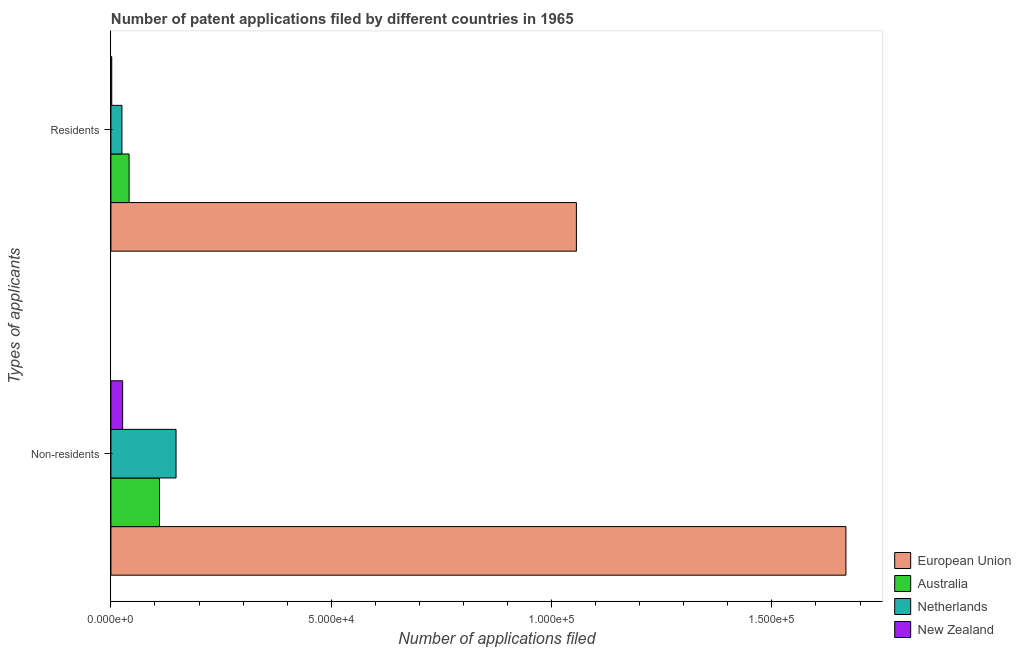How many different coloured bars are there?
Make the answer very short. 4. How many groups of bars are there?
Your answer should be compact. 2. Are the number of bars per tick equal to the number of legend labels?
Your answer should be compact. Yes. Are the number of bars on each tick of the Y-axis equal?
Give a very brief answer. Yes. What is the label of the 2nd group of bars from the top?
Your response must be concise. Non-residents. What is the number of patent applications by residents in European Union?
Keep it short and to the point. 1.06e+05. Across all countries, what is the maximum number of patent applications by non residents?
Your answer should be very brief. 1.67e+05. Across all countries, what is the minimum number of patent applications by non residents?
Offer a very short reply. 2662. In which country was the number of patent applications by non residents maximum?
Keep it short and to the point. European Union. In which country was the number of patent applications by non residents minimum?
Provide a succinct answer. New Zealand. What is the total number of patent applications by residents in the graph?
Offer a terse response. 1.12e+05. What is the difference between the number of patent applications by residents in New Zealand and that in Australia?
Offer a very short reply. -3935. What is the difference between the number of patent applications by residents in European Union and the number of patent applications by non residents in New Zealand?
Your answer should be very brief. 1.03e+05. What is the average number of patent applications by non residents per country?
Make the answer very short. 4.88e+04. What is the difference between the number of patent applications by residents and number of patent applications by non residents in European Union?
Your answer should be very brief. -6.12e+04. What is the ratio of the number of patent applications by non residents in Australia to that in European Union?
Your answer should be compact. 0.07. Is the number of patent applications by residents in European Union less than that in Australia?
Your answer should be compact. No. What does the 1st bar from the top in Residents represents?
Keep it short and to the point. New Zealand. What does the 4th bar from the bottom in Residents represents?
Your response must be concise. New Zealand. How many bars are there?
Provide a succinct answer. 8. How many countries are there in the graph?
Offer a terse response. 4. What is the difference between two consecutive major ticks on the X-axis?
Your answer should be very brief. 5.00e+04. Are the values on the major ticks of X-axis written in scientific E-notation?
Give a very brief answer. Yes. Does the graph contain any zero values?
Offer a very short reply. No. Where does the legend appear in the graph?
Provide a short and direct response. Bottom right. What is the title of the graph?
Keep it short and to the point. Number of patent applications filed by different countries in 1965. Does "Costa Rica" appear as one of the legend labels in the graph?
Your answer should be very brief. No. What is the label or title of the X-axis?
Make the answer very short. Number of applications filed. What is the label or title of the Y-axis?
Offer a very short reply. Types of applicants. What is the Number of applications filed of European Union in Non-residents?
Your answer should be very brief. 1.67e+05. What is the Number of applications filed of Australia in Non-residents?
Offer a very short reply. 1.10e+04. What is the Number of applications filed in Netherlands in Non-residents?
Provide a succinct answer. 1.48e+04. What is the Number of applications filed in New Zealand in Non-residents?
Provide a short and direct response. 2662. What is the Number of applications filed in European Union in Residents?
Provide a short and direct response. 1.06e+05. What is the Number of applications filed of Australia in Residents?
Your response must be concise. 4123. What is the Number of applications filed in Netherlands in Residents?
Offer a terse response. 2505. What is the Number of applications filed of New Zealand in Residents?
Make the answer very short. 188. Across all Types of applicants, what is the maximum Number of applications filed of European Union?
Provide a short and direct response. 1.67e+05. Across all Types of applicants, what is the maximum Number of applications filed in Australia?
Your response must be concise. 1.10e+04. Across all Types of applicants, what is the maximum Number of applications filed in Netherlands?
Your answer should be very brief. 1.48e+04. Across all Types of applicants, what is the maximum Number of applications filed of New Zealand?
Provide a succinct answer. 2662. Across all Types of applicants, what is the minimum Number of applications filed of European Union?
Provide a short and direct response. 1.06e+05. Across all Types of applicants, what is the minimum Number of applications filed of Australia?
Keep it short and to the point. 4123. Across all Types of applicants, what is the minimum Number of applications filed of Netherlands?
Your answer should be compact. 2505. Across all Types of applicants, what is the minimum Number of applications filed in New Zealand?
Your answer should be very brief. 188. What is the total Number of applications filed in European Union in the graph?
Your response must be concise. 2.72e+05. What is the total Number of applications filed in Australia in the graph?
Ensure brevity in your answer.  1.52e+04. What is the total Number of applications filed of Netherlands in the graph?
Give a very brief answer. 1.73e+04. What is the total Number of applications filed of New Zealand in the graph?
Keep it short and to the point. 2850. What is the difference between the Number of applications filed in European Union in Non-residents and that in Residents?
Offer a very short reply. 6.12e+04. What is the difference between the Number of applications filed of Australia in Non-residents and that in Residents?
Offer a terse response. 6904. What is the difference between the Number of applications filed of Netherlands in Non-residents and that in Residents?
Provide a short and direct response. 1.23e+04. What is the difference between the Number of applications filed in New Zealand in Non-residents and that in Residents?
Keep it short and to the point. 2474. What is the difference between the Number of applications filed of European Union in Non-residents and the Number of applications filed of Australia in Residents?
Provide a short and direct response. 1.63e+05. What is the difference between the Number of applications filed of European Union in Non-residents and the Number of applications filed of Netherlands in Residents?
Offer a terse response. 1.64e+05. What is the difference between the Number of applications filed in European Union in Non-residents and the Number of applications filed in New Zealand in Residents?
Your response must be concise. 1.67e+05. What is the difference between the Number of applications filed of Australia in Non-residents and the Number of applications filed of Netherlands in Residents?
Offer a terse response. 8522. What is the difference between the Number of applications filed in Australia in Non-residents and the Number of applications filed in New Zealand in Residents?
Your response must be concise. 1.08e+04. What is the difference between the Number of applications filed of Netherlands in Non-residents and the Number of applications filed of New Zealand in Residents?
Give a very brief answer. 1.46e+04. What is the average Number of applications filed in European Union per Types of applicants?
Your answer should be compact. 1.36e+05. What is the average Number of applications filed of Australia per Types of applicants?
Your response must be concise. 7575. What is the average Number of applications filed of Netherlands per Types of applicants?
Offer a very short reply. 8642. What is the average Number of applications filed in New Zealand per Types of applicants?
Provide a short and direct response. 1425. What is the difference between the Number of applications filed of European Union and Number of applications filed of Australia in Non-residents?
Your response must be concise. 1.56e+05. What is the difference between the Number of applications filed of European Union and Number of applications filed of Netherlands in Non-residents?
Keep it short and to the point. 1.52e+05. What is the difference between the Number of applications filed of European Union and Number of applications filed of New Zealand in Non-residents?
Offer a very short reply. 1.64e+05. What is the difference between the Number of applications filed of Australia and Number of applications filed of Netherlands in Non-residents?
Provide a short and direct response. -3752. What is the difference between the Number of applications filed of Australia and Number of applications filed of New Zealand in Non-residents?
Offer a very short reply. 8365. What is the difference between the Number of applications filed of Netherlands and Number of applications filed of New Zealand in Non-residents?
Provide a succinct answer. 1.21e+04. What is the difference between the Number of applications filed in European Union and Number of applications filed in Australia in Residents?
Your response must be concise. 1.02e+05. What is the difference between the Number of applications filed of European Union and Number of applications filed of Netherlands in Residents?
Provide a succinct answer. 1.03e+05. What is the difference between the Number of applications filed of European Union and Number of applications filed of New Zealand in Residents?
Offer a very short reply. 1.05e+05. What is the difference between the Number of applications filed in Australia and Number of applications filed in Netherlands in Residents?
Ensure brevity in your answer.  1618. What is the difference between the Number of applications filed in Australia and Number of applications filed in New Zealand in Residents?
Provide a short and direct response. 3935. What is the difference between the Number of applications filed of Netherlands and Number of applications filed of New Zealand in Residents?
Keep it short and to the point. 2317. What is the ratio of the Number of applications filed of European Union in Non-residents to that in Residents?
Your answer should be very brief. 1.58. What is the ratio of the Number of applications filed in Australia in Non-residents to that in Residents?
Keep it short and to the point. 2.67. What is the ratio of the Number of applications filed of Netherlands in Non-residents to that in Residents?
Offer a terse response. 5.9. What is the ratio of the Number of applications filed of New Zealand in Non-residents to that in Residents?
Your answer should be very brief. 14.16. What is the difference between the highest and the second highest Number of applications filed of European Union?
Give a very brief answer. 6.12e+04. What is the difference between the highest and the second highest Number of applications filed in Australia?
Offer a very short reply. 6904. What is the difference between the highest and the second highest Number of applications filed in Netherlands?
Keep it short and to the point. 1.23e+04. What is the difference between the highest and the second highest Number of applications filed in New Zealand?
Your answer should be very brief. 2474. What is the difference between the highest and the lowest Number of applications filed of European Union?
Keep it short and to the point. 6.12e+04. What is the difference between the highest and the lowest Number of applications filed in Australia?
Provide a short and direct response. 6904. What is the difference between the highest and the lowest Number of applications filed of Netherlands?
Offer a very short reply. 1.23e+04. What is the difference between the highest and the lowest Number of applications filed in New Zealand?
Provide a succinct answer. 2474. 